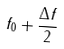<formula> <loc_0><loc_0><loc_500><loc_500>f _ { 0 } + \frac { \Delta f } { 2 }</formula> 